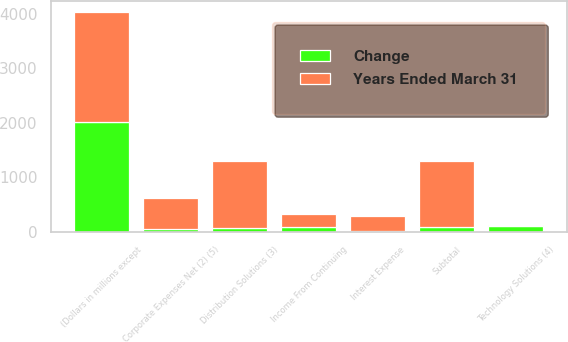<chart> <loc_0><loc_0><loc_500><loc_500><stacked_bar_chart><ecel><fcel>(Dollars in millions except<fcel>Distribution Solutions (3)<fcel>Technology Solutions (4)<fcel>Subtotal<fcel>Corporate Expenses Net (2) (5)<fcel>Interest Expense<fcel>Income From Continuing<nl><fcel>Years Ended March 31<fcel>2018<fcel>1231<fcel>23<fcel>1208<fcel>564<fcel>283<fcel>239<nl><fcel>Change<fcel>2018<fcel>63<fcel>101<fcel>84<fcel>50<fcel>8<fcel>97<nl></chart> 